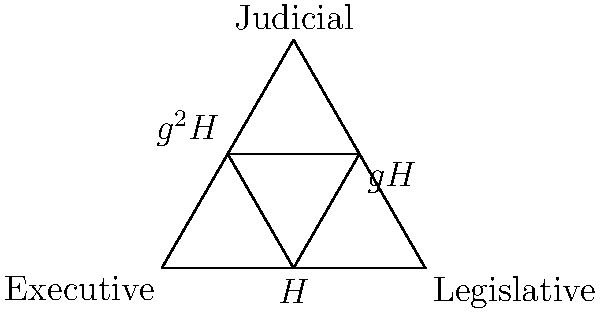In the diagram, the triangle represents the three branches of government, with the inner triangle showing cosets of a subgroup $H$ of the symmetry group of the governmental structure. If $g$ is a generator of the group, and $|G:H| = 3$, what is the order of $g$? To solve this problem, let's follow these steps:

1) The diagram shows three cosets: $H$, $gH$, and $g^2H$.

2) The fact that there are three distinct cosets tells us that the index of $H$ in $G$ is 3, which is confirmed by the given information $|G:H| = 3$.

3) In group theory, if $g$ is an element of a group $G$, then the cosets $H$, $gH$, $g^2H$, ..., $g^{n-1}H$ are all distinct if and only if $n$ is the smallest positive integer such that $g^n \in H$.

4) In this case, we see that $g^3H = H$, because after $g^2H$, we cycle back to $H$.

5) This means that $g^3 \in H$, and 3 is the smallest positive integer with this property.

6) The order of an element is the smallest positive integer $k$ such that $g^k = e$ (the identity element).

7) Since $g^3 \in H$, and $H$ is a subgroup, we know that $g^3 = e$.

8) Therefore, the order of $g$ is 3.

This aligns with the political interpretation: if $g$ represents a "rotation" of power among the three branches, it takes three applications of $g$ to return to the original state.
Answer: 3 